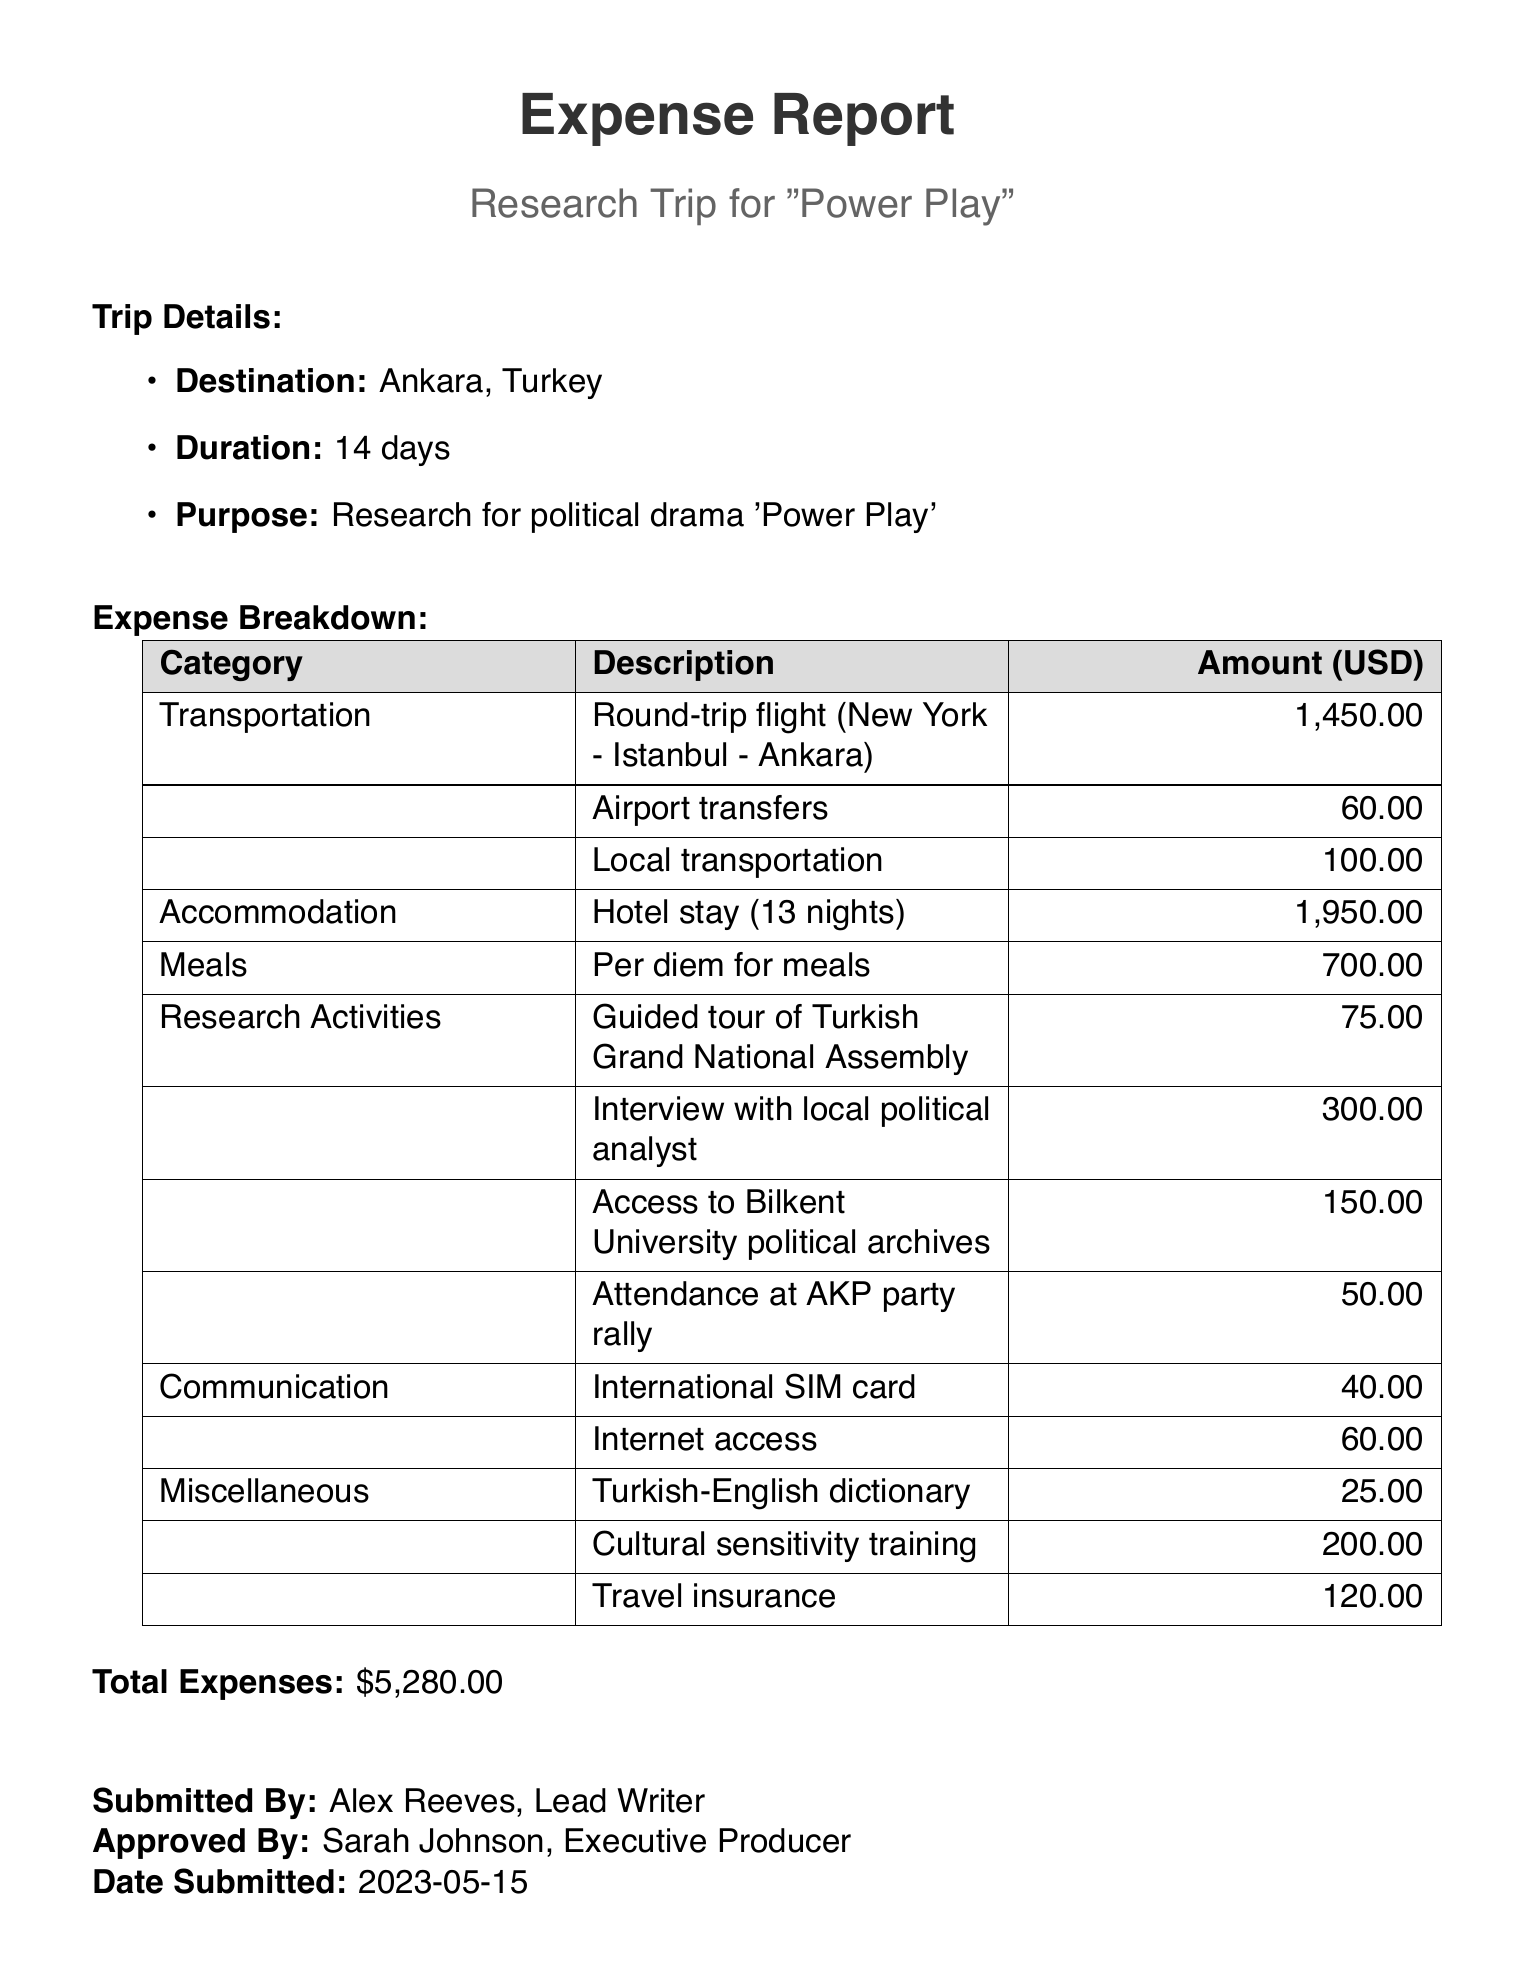What is the trip purpose? The trip purpose is stated at the beginning of the document as research for the political drama 'Power Play'.
Answer: Research for political drama 'Power Play' What is the duration of the trip? The duration is specified as the length of the trip, which is 14 days.
Answer: 14 days Who submitted the expense report? The submitted by section of the document lists the name of the individual who submitted the report.
Answer: Alex Reeves, Lead Writer What is the total amount of expenses? The total expenses are provided near the end of the document as a summary of all costs incurred during the trip.
Answer: $5,280.00 How much was spent on meals? The meals category specifies the amount allocated for meals during the trip.
Answer: $700.00 What category includes access to political archives? The category related to activities that involved researching political information is titled "Research Activities".
Answer: Research Activities How much was spent on cultural sensitivity training? The expense for cultural sensitivity training is listed under the miscellaneous category, which shows its cost.
Answer: $200.00 What vendor provided the international SIM card? The vendor for the international SIM card is mentioned in the communication category, indicating where it was obtained.
Answer: Turkcell What was the cost of local transportation? The cost of local transportation is explicitly mentioned under the transportation category in the expense report.
Answer: $100.00 Which organization's event did the trip attendee attend? The event attended is recorded as an AKP party rally, detailing the political organization involved.
Answer: AKP party rally 